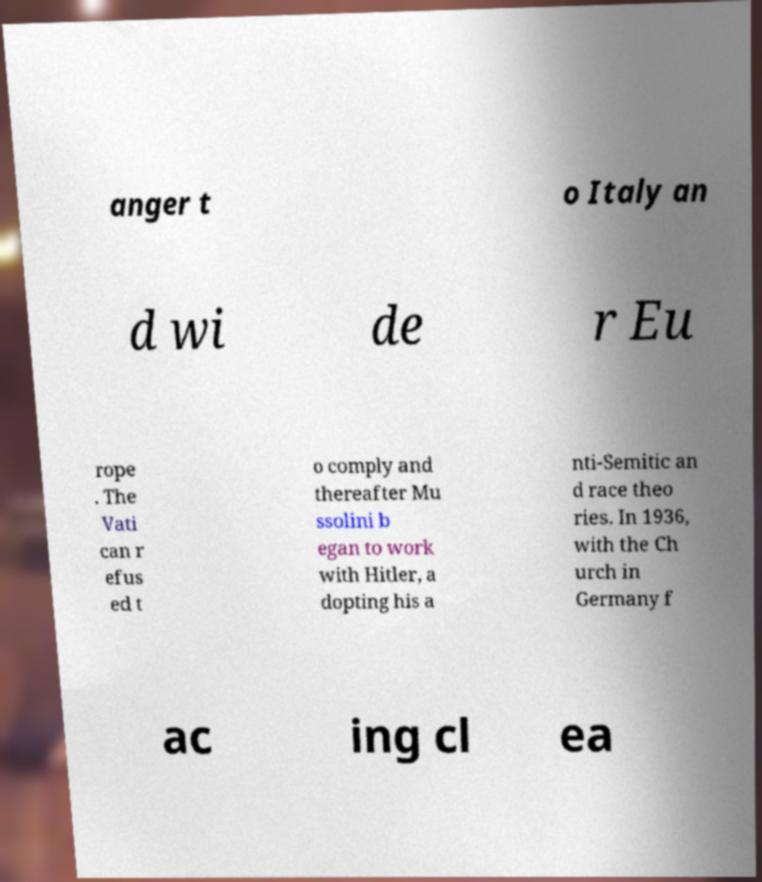What messages or text are displayed in this image? I need them in a readable, typed format. anger t o Italy an d wi de r Eu rope . The Vati can r efus ed t o comply and thereafter Mu ssolini b egan to work with Hitler, a dopting his a nti-Semitic an d race theo ries. In 1936, with the Ch urch in Germany f ac ing cl ea 